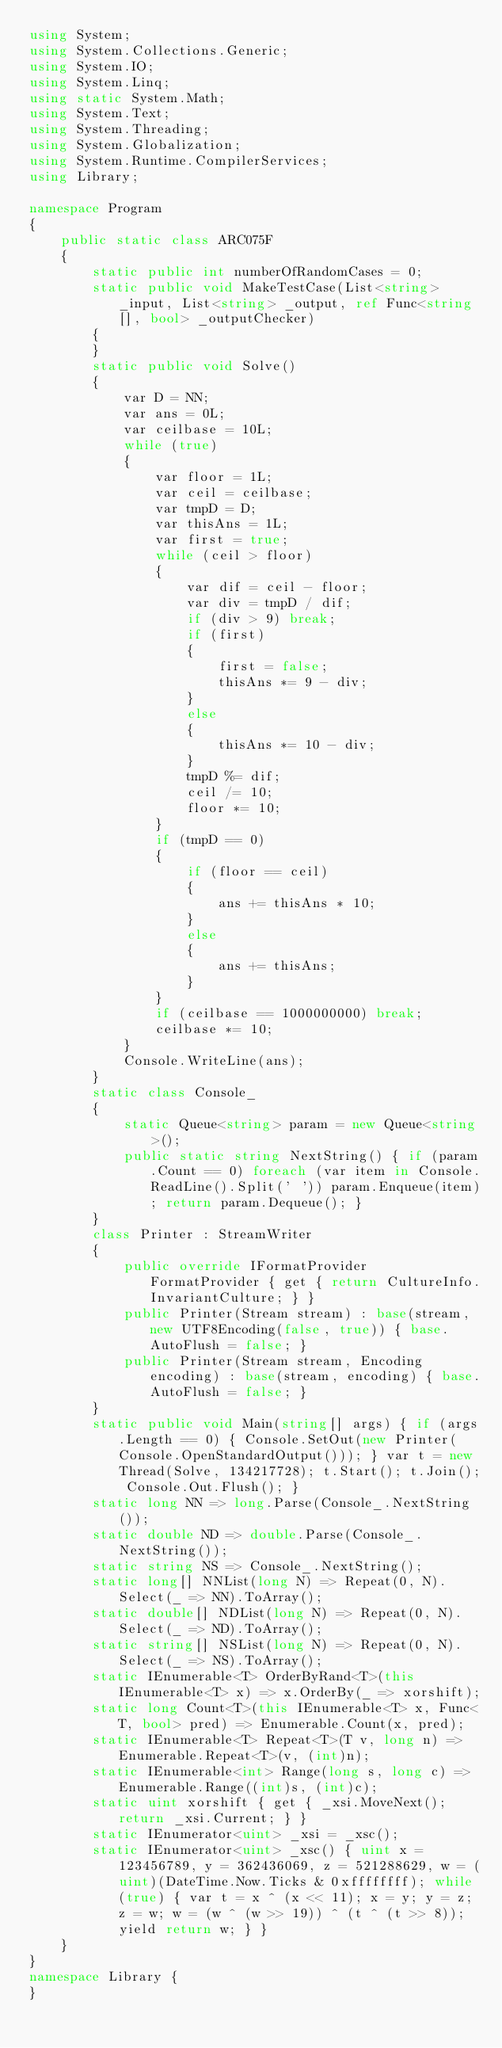Convert code to text. <code><loc_0><loc_0><loc_500><loc_500><_C#_>using System;
using System.Collections.Generic;
using System.IO;
using System.Linq;
using static System.Math;
using System.Text;
using System.Threading;
using System.Globalization;
using System.Runtime.CompilerServices;
using Library;

namespace Program
{
    public static class ARC075F
    {
        static public int numberOfRandomCases = 0;
        static public void MakeTestCase(List<string> _input, List<string> _output, ref Func<string[], bool> _outputChecker)
        {
        }
        static public void Solve()
        {
            var D = NN;
            var ans = 0L;
            var ceilbase = 10L;
            while (true)
            {
                var floor = 1L;
                var ceil = ceilbase;
                var tmpD = D;
                var thisAns = 1L;
                var first = true;
                while (ceil > floor)
                {
                    var dif = ceil - floor;
                    var div = tmpD / dif;
                    if (div > 9) break;
                    if (first)
                    {
                        first = false;
                        thisAns *= 9 - div;
                    }
                    else
                    {
                        thisAns *= 10 - div;
                    }
                    tmpD %= dif;
                    ceil /= 10;
                    floor *= 10;
                }
                if (tmpD == 0)
                {
                    if (floor == ceil)
                    {
                        ans += thisAns * 10;
                    }
                    else
                    {
                        ans += thisAns;
                    }
                }
                if (ceilbase == 1000000000) break;
                ceilbase *= 10;
            }
            Console.WriteLine(ans);
        }
        static class Console_
        {
            static Queue<string> param = new Queue<string>();
            public static string NextString() { if (param.Count == 0) foreach (var item in Console.ReadLine().Split(' ')) param.Enqueue(item); return param.Dequeue(); }
        }
        class Printer : StreamWriter
        {
            public override IFormatProvider FormatProvider { get { return CultureInfo.InvariantCulture; } }
            public Printer(Stream stream) : base(stream, new UTF8Encoding(false, true)) { base.AutoFlush = false; }
            public Printer(Stream stream, Encoding encoding) : base(stream, encoding) { base.AutoFlush = false; }
        }
        static public void Main(string[] args) { if (args.Length == 0) { Console.SetOut(new Printer(Console.OpenStandardOutput())); } var t = new Thread(Solve, 134217728); t.Start(); t.Join(); Console.Out.Flush(); }
        static long NN => long.Parse(Console_.NextString());
        static double ND => double.Parse(Console_.NextString());
        static string NS => Console_.NextString();
        static long[] NNList(long N) => Repeat(0, N).Select(_ => NN).ToArray();
        static double[] NDList(long N) => Repeat(0, N).Select(_ => ND).ToArray();
        static string[] NSList(long N) => Repeat(0, N).Select(_ => NS).ToArray();
        static IEnumerable<T> OrderByRand<T>(this IEnumerable<T> x) => x.OrderBy(_ => xorshift);
        static long Count<T>(this IEnumerable<T> x, Func<T, bool> pred) => Enumerable.Count(x, pred);
        static IEnumerable<T> Repeat<T>(T v, long n) => Enumerable.Repeat<T>(v, (int)n);
        static IEnumerable<int> Range(long s, long c) => Enumerable.Range((int)s, (int)c);
        static uint xorshift { get { _xsi.MoveNext(); return _xsi.Current; } }
        static IEnumerator<uint> _xsi = _xsc();
        static IEnumerator<uint> _xsc() { uint x = 123456789, y = 362436069, z = 521288629, w = (uint)(DateTime.Now.Ticks & 0xffffffff); while (true) { var t = x ^ (x << 11); x = y; y = z; z = w; w = (w ^ (w >> 19)) ^ (t ^ (t >> 8)); yield return w; } }
    }
}
namespace Library {
}
</code> 